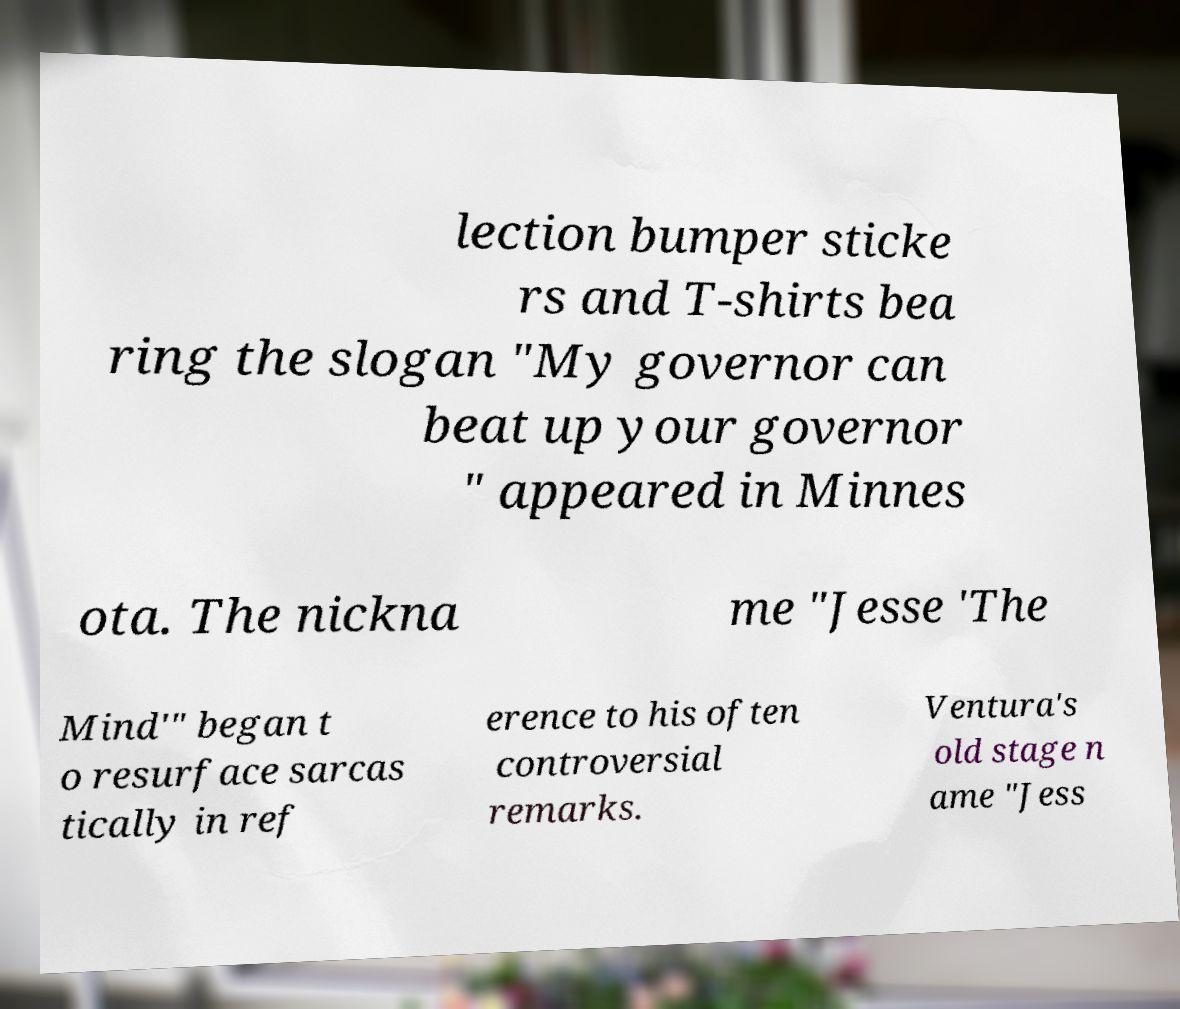Please read and relay the text visible in this image. What does it say? lection bumper sticke rs and T-shirts bea ring the slogan "My governor can beat up your governor " appeared in Minnes ota. The nickna me "Jesse 'The Mind'" began t o resurface sarcas tically in ref erence to his often controversial remarks. Ventura's old stage n ame "Jess 